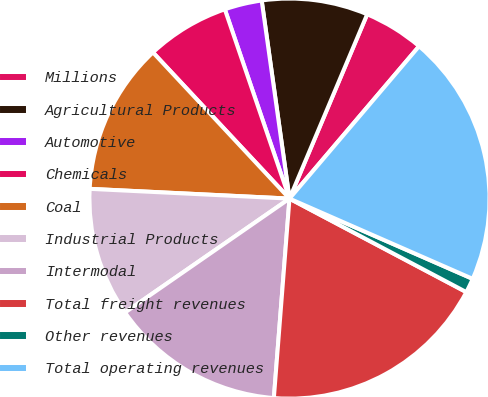<chart> <loc_0><loc_0><loc_500><loc_500><pie_chart><fcel>Millions<fcel>Agricultural Products<fcel>Automotive<fcel>Chemicals<fcel>Coal<fcel>Industrial Products<fcel>Intermodal<fcel>Total freight revenues<fcel>Other revenues<fcel>Total operating revenues<nl><fcel>4.87%<fcel>8.57%<fcel>3.02%<fcel>6.72%<fcel>12.27%<fcel>10.42%<fcel>14.12%<fcel>18.51%<fcel>1.17%<fcel>20.36%<nl></chart> 